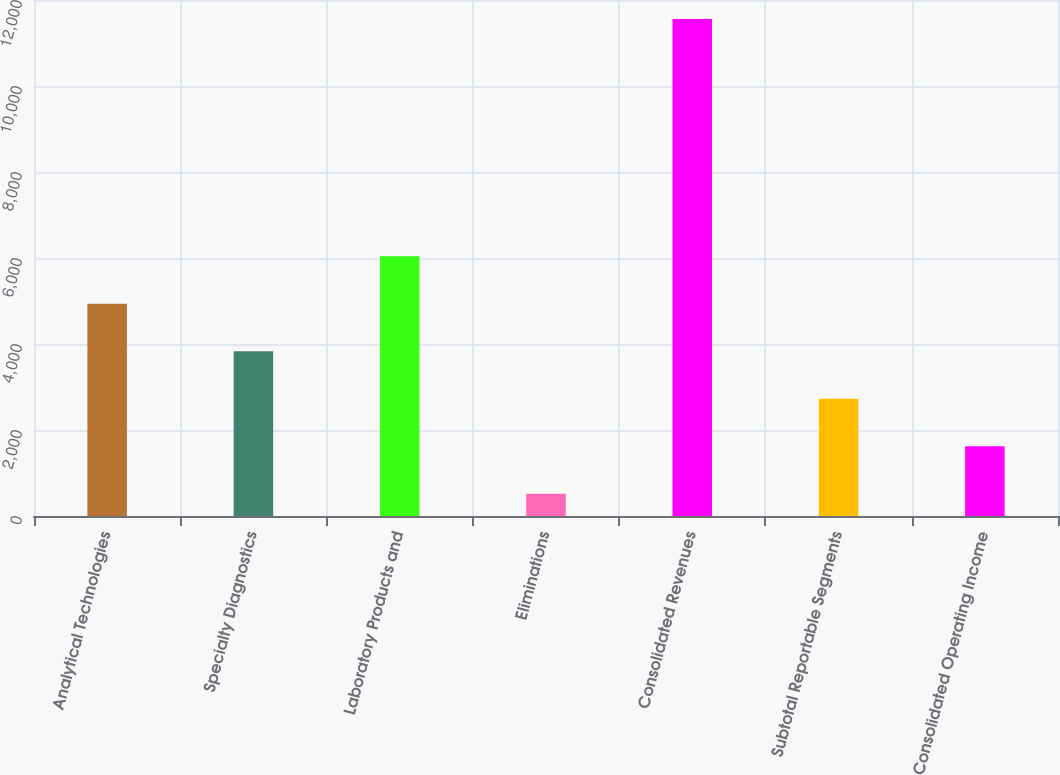Convert chart. <chart><loc_0><loc_0><loc_500><loc_500><bar_chart><fcel>Analytical Technologies<fcel>Specialty Diagnostics<fcel>Laboratory Products and<fcel>Eliminations<fcel>Consolidated Revenues<fcel>Subtotal Reportable Segments<fcel>Consolidated Operating Income<nl><fcel>4935.16<fcel>3831.22<fcel>6039.1<fcel>519.4<fcel>11558.8<fcel>2727.28<fcel>1623.34<nl></chart> 